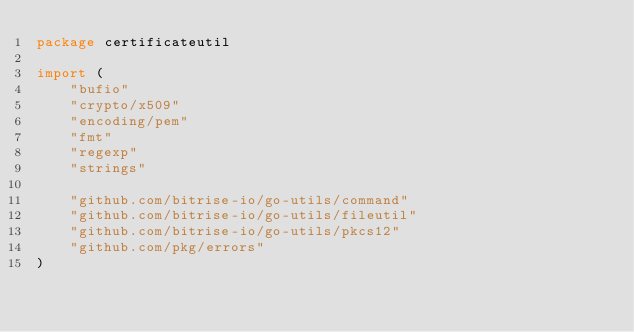<code> <loc_0><loc_0><loc_500><loc_500><_Go_>package certificateutil

import (
	"bufio"
	"crypto/x509"
	"encoding/pem"
	"fmt"
	"regexp"
	"strings"

	"github.com/bitrise-io/go-utils/command"
	"github.com/bitrise-io/go-utils/fileutil"
	"github.com/bitrise-io/go-utils/pkcs12"
	"github.com/pkg/errors"
)
</code> 